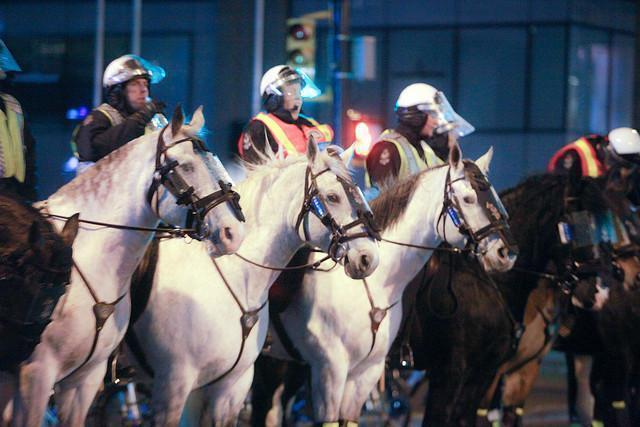What body part is protected by the attachment on the helmets they are wearing?
Indicate the correct response by choosing from the four available options to answer the question.
Options: Arms, neck, throat, face. Face. 